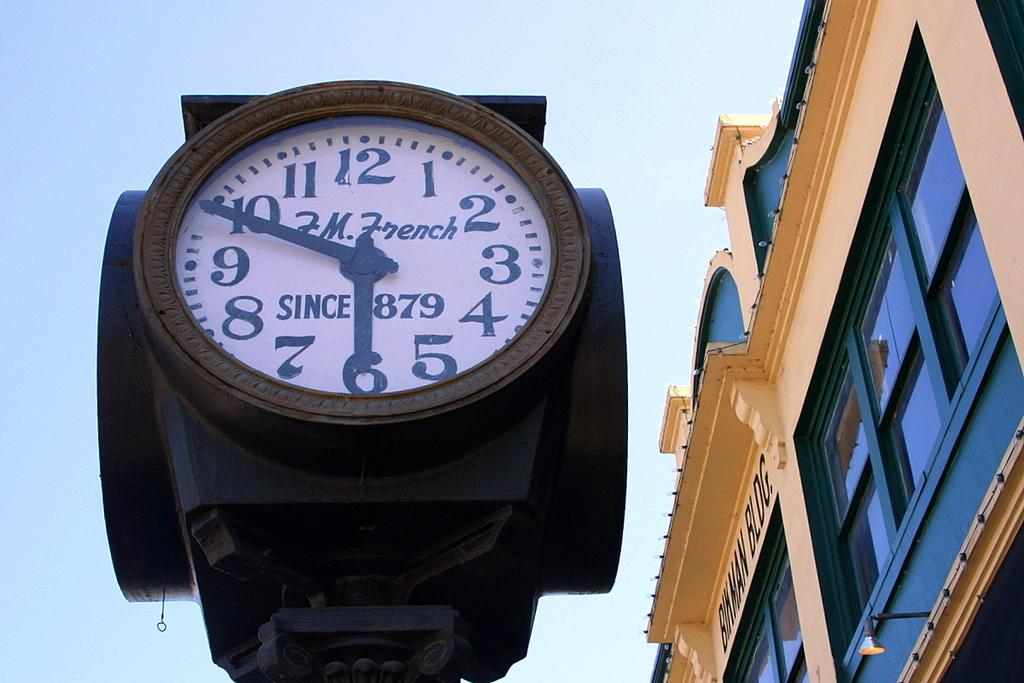<image>
Provide a brief description of the given image. A FM French clock has been standing since 1879. 